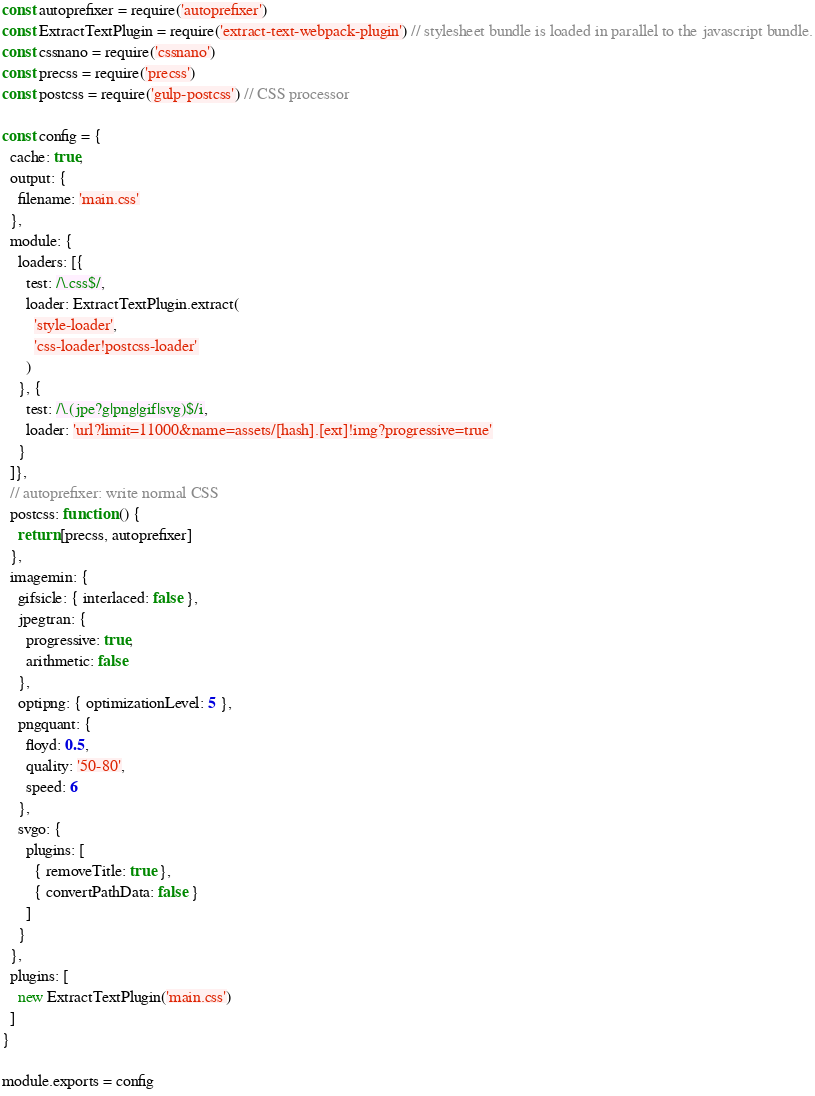Convert code to text. <code><loc_0><loc_0><loc_500><loc_500><_JavaScript_>const autoprefixer = require('autoprefixer')
const ExtractTextPlugin = require('extract-text-webpack-plugin') // stylesheet bundle is loaded in parallel to the javascript bundle.
const cssnano = require('cssnano')
const precss = require('precss')
const postcss = require('gulp-postcss') // CSS processor

const config = {
  cache: true,
  output: {
    filename: 'main.css'
  },
  module: {
    loaders: [{
      test: /\.css$/,
      loader: ExtractTextPlugin.extract(
        'style-loader',
        'css-loader!postcss-loader'
      )
    }, {
      test: /\.(jpe?g|png|gif|svg)$/i,
      loader: 'url?limit=11000&name=assets/[hash].[ext]!img?progressive=true'
    }
  ]},
  // autoprefixer: write normal CSS
  postcss: function () {
    return [precss, autoprefixer]
  },
  imagemin: {
    gifsicle: { interlaced: false },
    jpegtran: {
      progressive: true,
      arithmetic: false
    },
    optipng: { optimizationLevel: 5 },
    pngquant: {
      floyd: 0.5,
      quality: '50-80',
      speed: 6
    },
    svgo: {
      plugins: [
        { removeTitle: true },
        { convertPathData: false }
      ]
    }
  },
  plugins: [
    new ExtractTextPlugin('main.css')
  ]
}

module.exports = config
</code> 